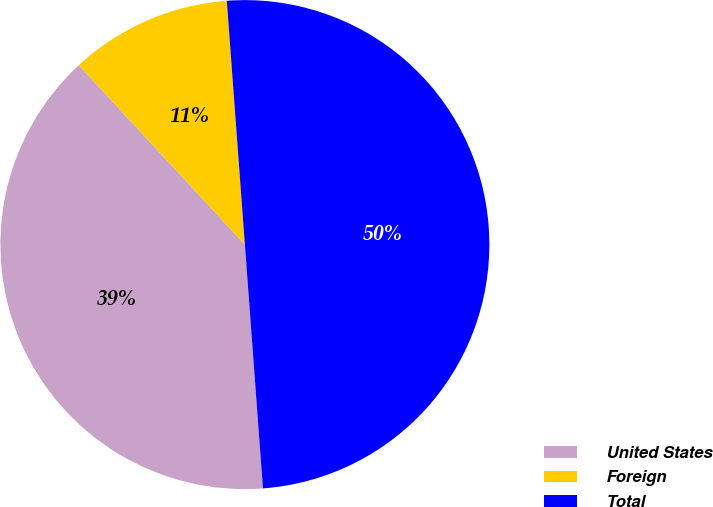Convert chart to OTSL. <chart><loc_0><loc_0><loc_500><loc_500><pie_chart><fcel>United States<fcel>Foreign<fcel>Total<nl><fcel>39.29%<fcel>10.71%<fcel>50.0%<nl></chart> 